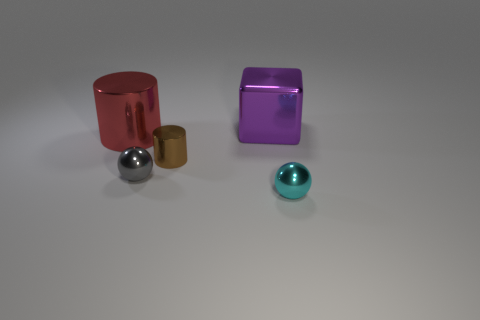How many things are metal things on the left side of the purple block or large things that are on the left side of the large shiny cube?
Provide a short and direct response. 3. How many other things are there of the same size as the gray ball?
Offer a very short reply. 2. What is the shape of the large metallic thing that is on the right side of the gray metal thing that is left of the tiny cyan ball?
Keep it short and to the point. Cube. Is there anything else that has the same color as the cube?
Offer a terse response. No. The block has what color?
Offer a very short reply. Purple. Are there any balls?
Your response must be concise. Yes. Are there any tiny brown shiny things behind the brown cylinder?
Your answer should be compact. No. How many other objects are the same shape as the large purple thing?
Offer a terse response. 0. There is a metallic ball that is on the right side of the cylinder in front of the red metal cylinder; what number of small cyan metallic spheres are to the left of it?
Give a very brief answer. 0. How many brown metal objects are the same shape as the big red metallic object?
Your answer should be compact. 1. 